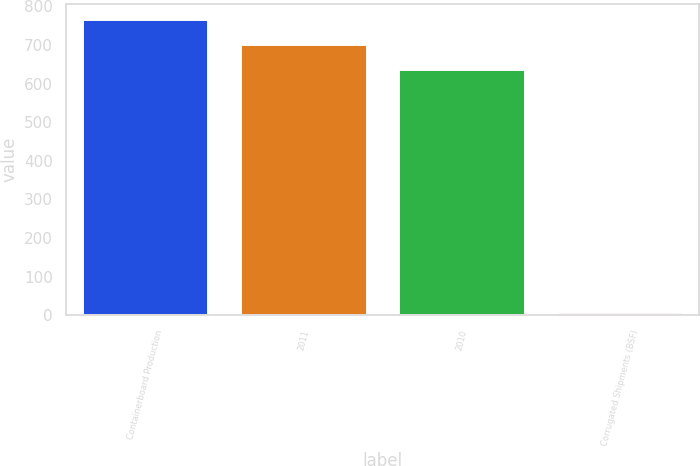Convert chart. <chart><loc_0><loc_0><loc_500><loc_500><bar_chart><fcel>Containerboard Production<fcel>2011<fcel>2010<fcel>Corrugated Shipments (BSF)<nl><fcel>767.64<fcel>703.32<fcel>639<fcel>8.8<nl></chart> 